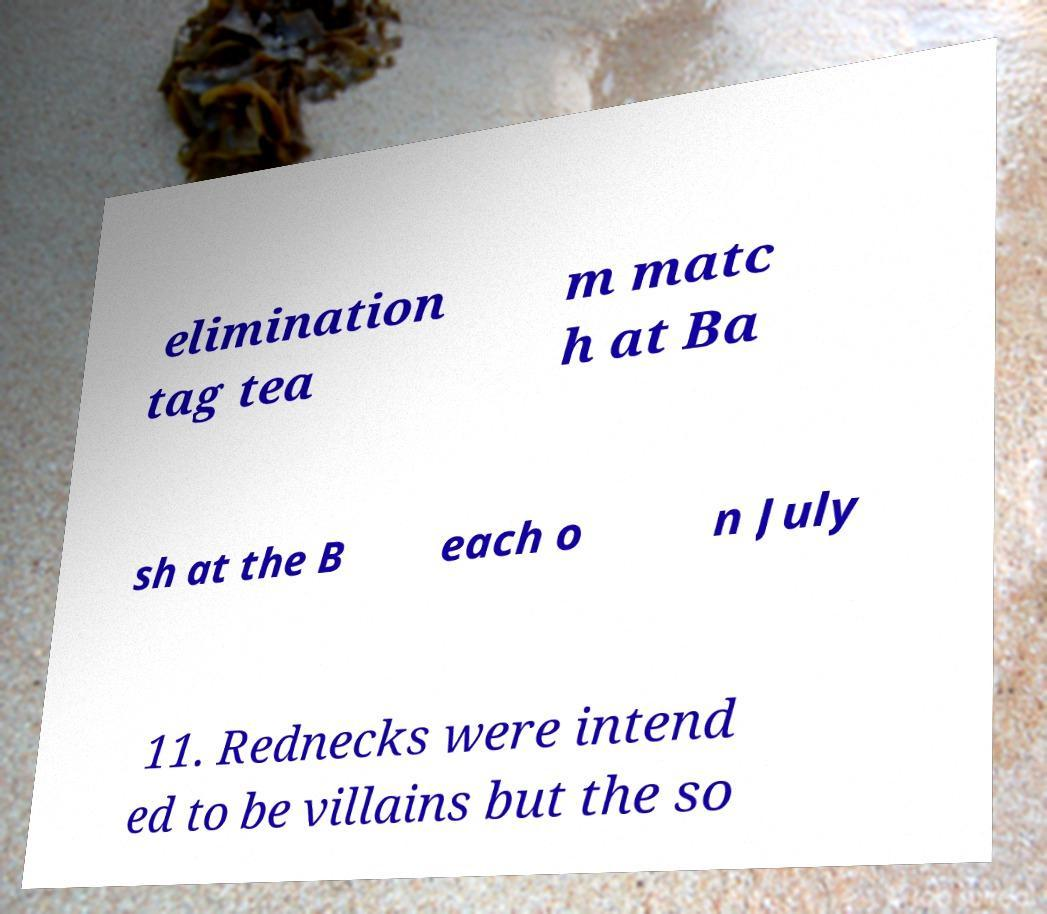There's text embedded in this image that I need extracted. Can you transcribe it verbatim? elimination tag tea m matc h at Ba sh at the B each o n July 11. Rednecks were intend ed to be villains but the so 